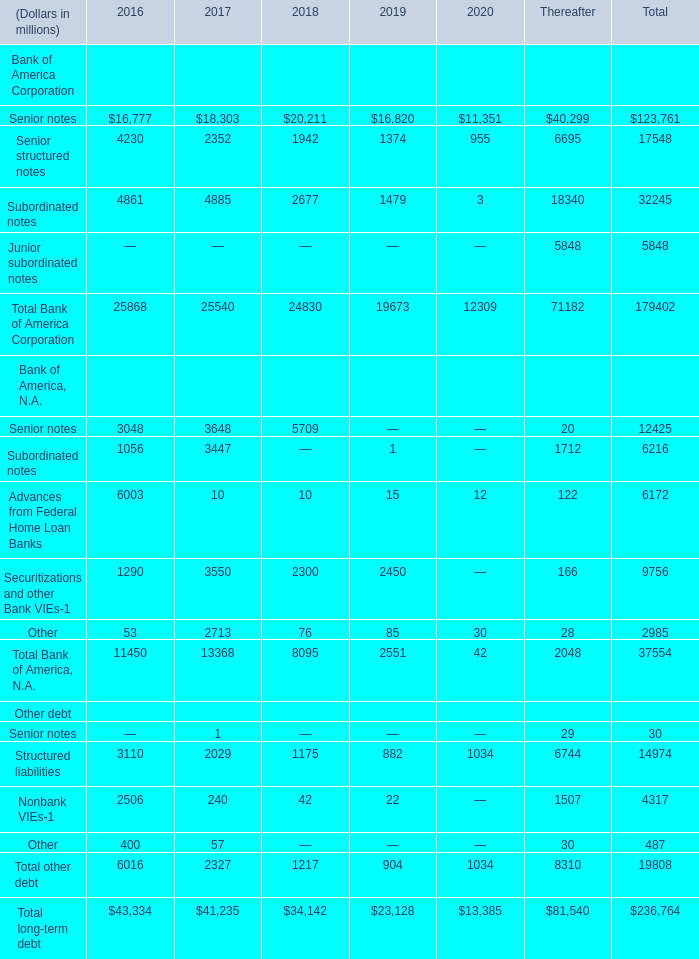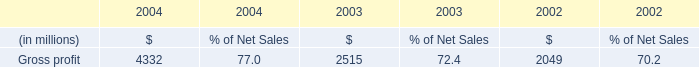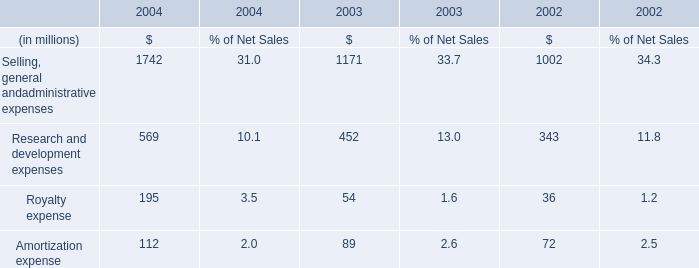What's the average of Senior notes of Bank of America Corporation in 2016, 2017, and 2018? (in millions) 
Computations: (((16777 + 18303) + 20211) / 3)
Answer: 18430.33333. 